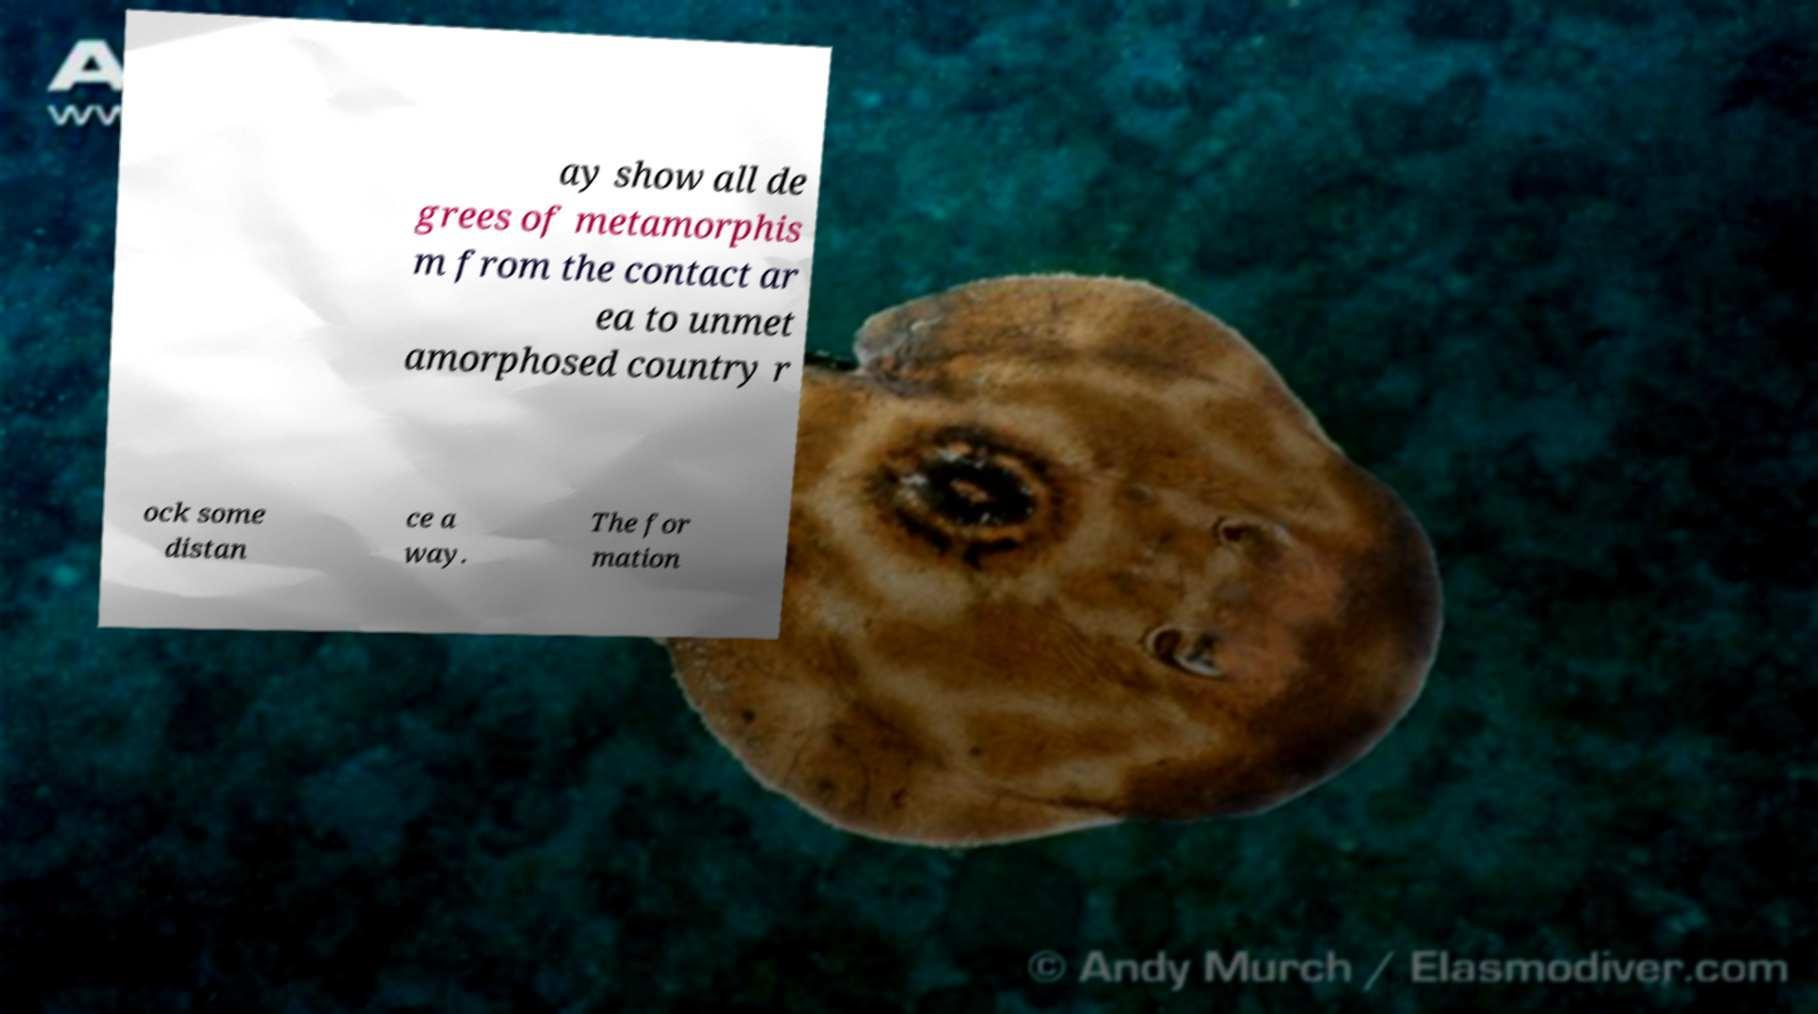There's text embedded in this image that I need extracted. Can you transcribe it verbatim? ay show all de grees of metamorphis m from the contact ar ea to unmet amorphosed country r ock some distan ce a way. The for mation 